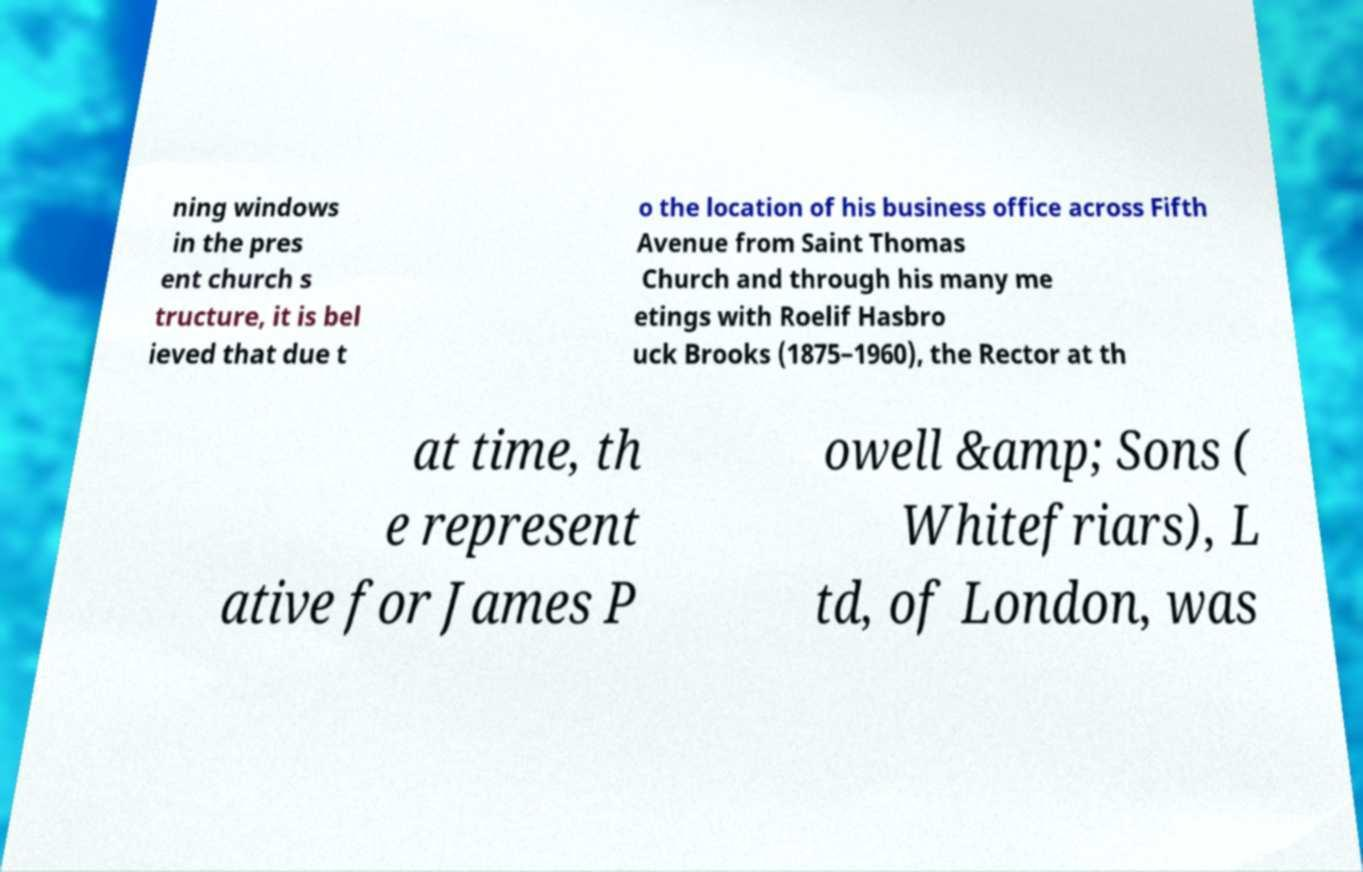Please read and relay the text visible in this image. What does it say? ning windows in the pres ent church s tructure, it is bel ieved that due t o the location of his business office across Fifth Avenue from Saint Thomas Church and through his many me etings with Roelif Hasbro uck Brooks (1875–1960), the Rector at th at time, th e represent ative for James P owell &amp; Sons ( Whitefriars), L td, of London, was 